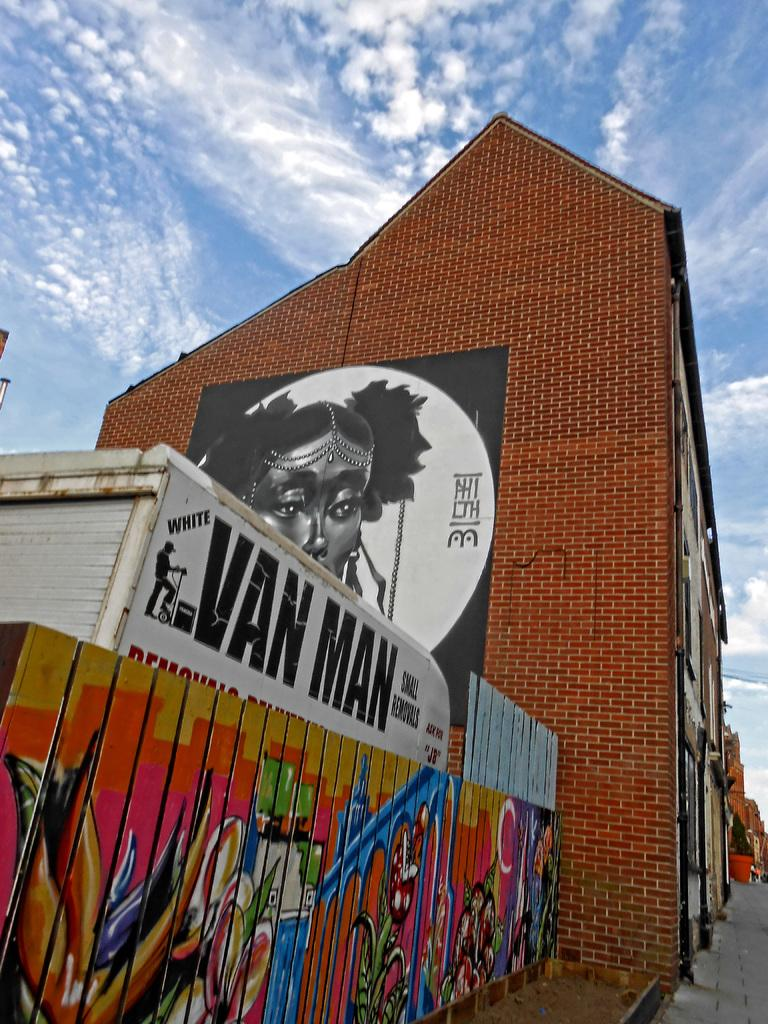What type of objects have paintings on them in the image? There are paintings on wooden blocks and bricks in the image. What structures can be seen in the image? There are buildings visible in the image. What is visible in the sky in the image? Clouds are present in the sky in the image. What type of war machinery can be seen in the image? There is no war machinery present in the image; it features paintings on wooden blocks and bricks, buildings, and clouds in the sky. 